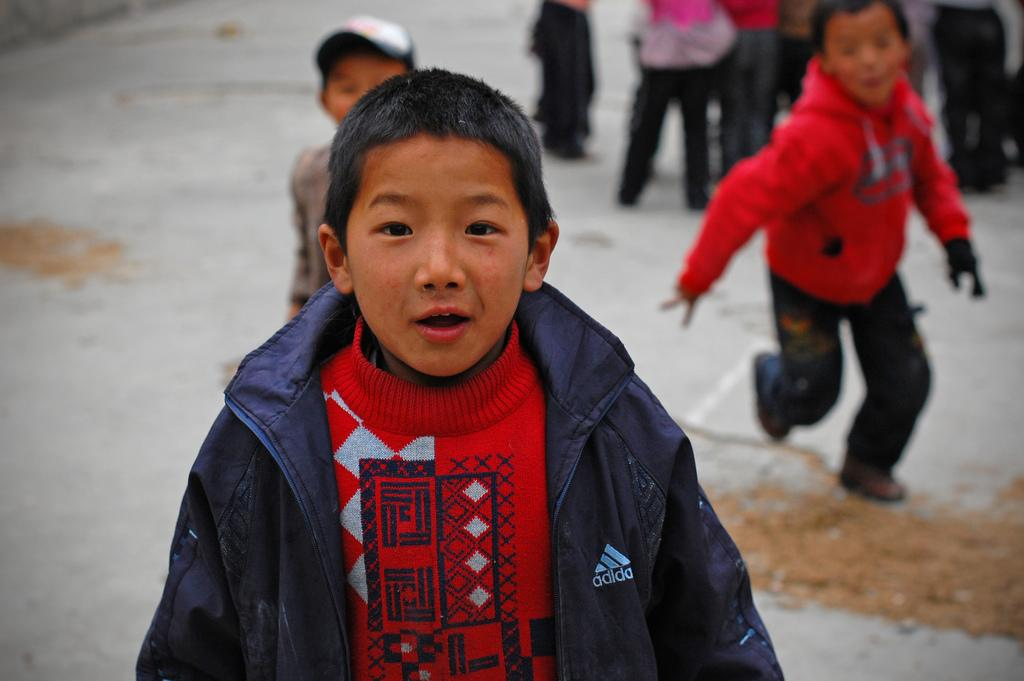What is the main subject in the center of the image? There is a child in the center of the image. What can be seen in the background of the image? There is a group of people standing on the ground in the background. What type of surface is the child and the group of people standing on? There is sand on the ground. What type of jar is being used to teach the child in the image? There is no jar or teaching activity present in the image. How does the child wash their hands in the image? There is no indication of handwashing or a wash station in the image. 